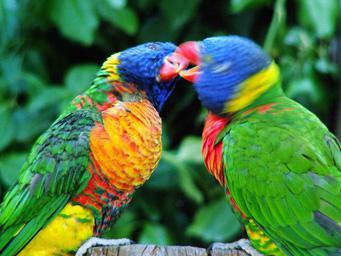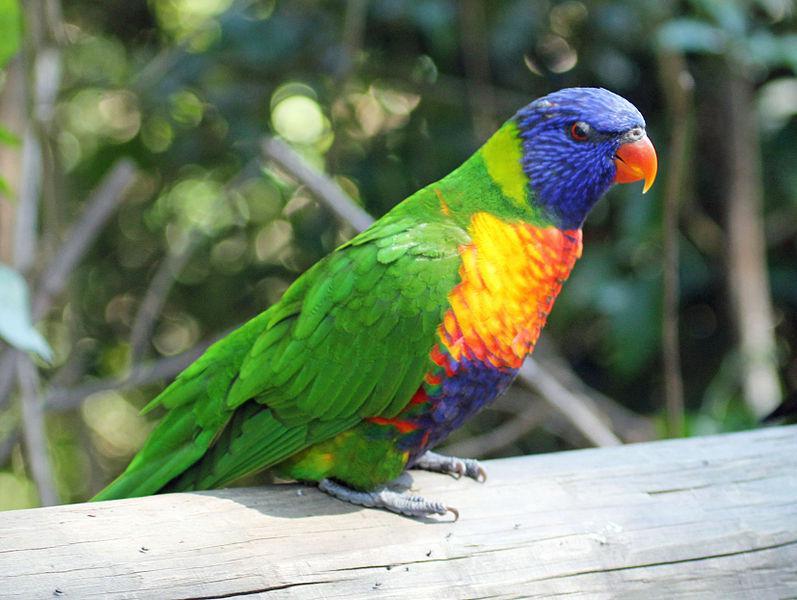The first image is the image on the left, the second image is the image on the right. Given the left and right images, does the statement "There are three birds" hold true? Answer yes or no. Yes. 